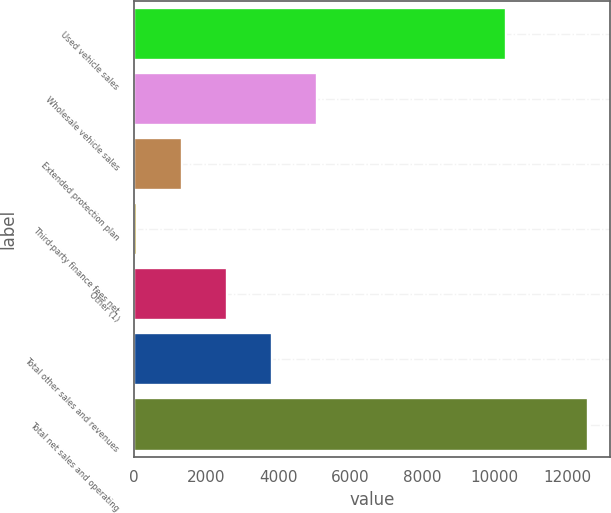<chart> <loc_0><loc_0><loc_500><loc_500><bar_chart><fcel>Used vehicle sales<fcel>Wholesale vehicle sales<fcel>Extended protection plan<fcel>Third-party finance fees net<fcel>Other (1)<fcel>Total other sales and revenues<fcel>Total net sales and operating<nl><fcel>10306.3<fcel>5079.4<fcel>1331.95<fcel>82.8<fcel>2581.1<fcel>3830.25<fcel>12574.3<nl></chart> 